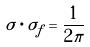<formula> <loc_0><loc_0><loc_500><loc_500>\sigma \cdot \sigma _ { f } = \frac { 1 } { 2 \pi }</formula> 